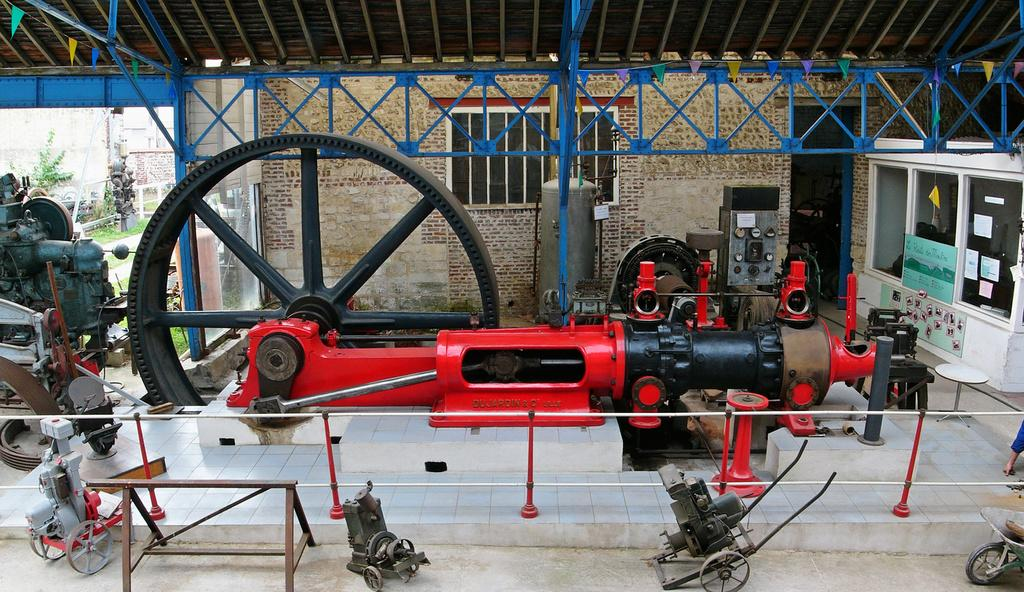What is: What type of objects are under the roof in the image? There are many machines and tools under a roof in the image. Can you describe the setting of the image? The location appears to be a building. What can be seen in the background of the image? There are trees and at least one other building in the background of the image. How many cows are grazing in the background of the image? There are no cows present in the image; it features trees and another building in the background. 